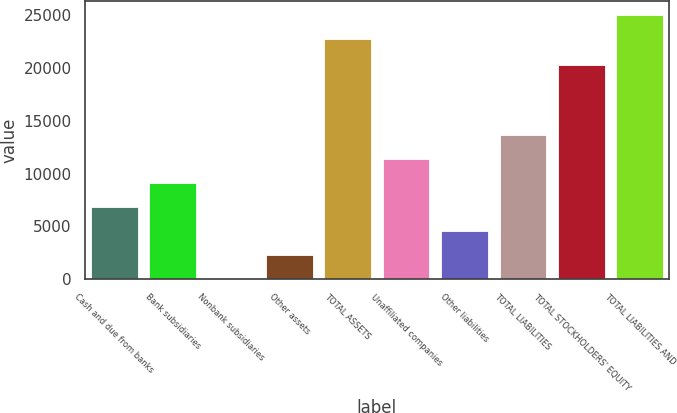Convert chart. <chart><loc_0><loc_0><loc_500><loc_500><bar_chart><fcel>Cash and due from banks<fcel>Bank subsidiaries<fcel>Nonbank subsidiaries<fcel>Other assets<fcel>TOTAL ASSETS<fcel>Unaffiliated companies<fcel>Other liabilities<fcel>TOTAL LIABILITIES<fcel>TOTAL STOCKHOLDERS' EQUITY<fcel>TOTAL LIABILITIES AND<nl><fcel>6875.8<fcel>9144.4<fcel>70<fcel>2338.6<fcel>22756<fcel>11413<fcel>4607.2<fcel>13681.6<fcel>20270<fcel>25024.6<nl></chart> 